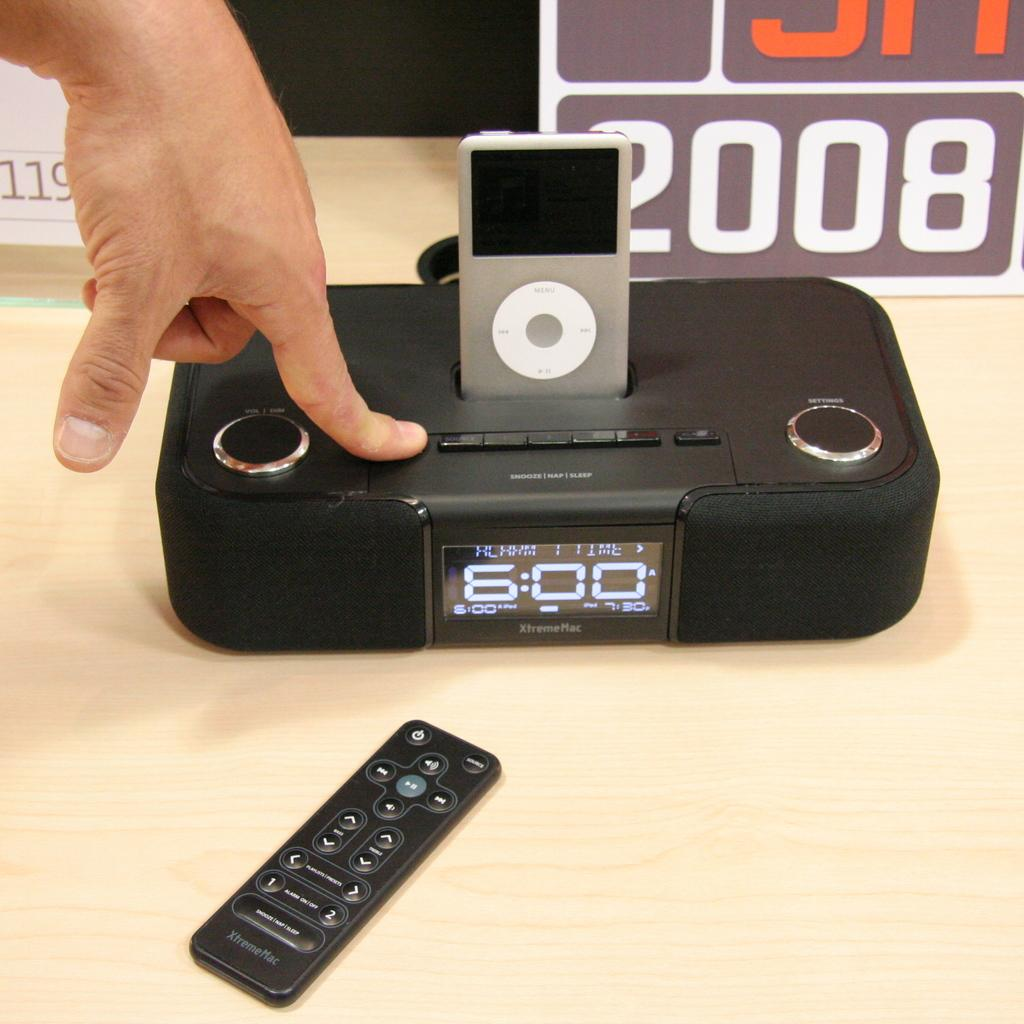<image>
Offer a succinct explanation of the picture presented. The time on the XtremeMac device is 6:00. 